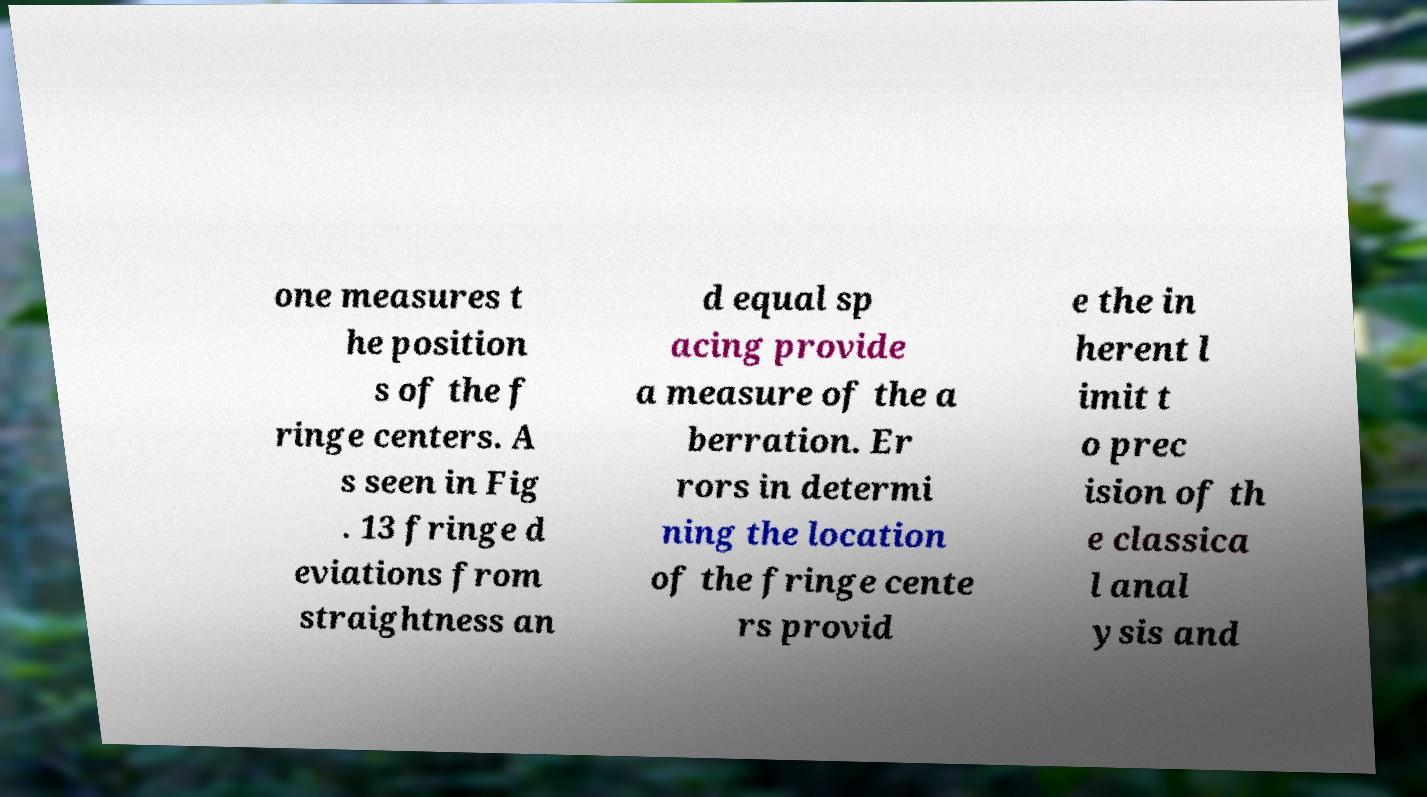For documentation purposes, I need the text within this image transcribed. Could you provide that? one measures t he position s of the f ringe centers. A s seen in Fig . 13 fringe d eviations from straightness an d equal sp acing provide a measure of the a berration. Er rors in determi ning the location of the fringe cente rs provid e the in herent l imit t o prec ision of th e classica l anal ysis and 